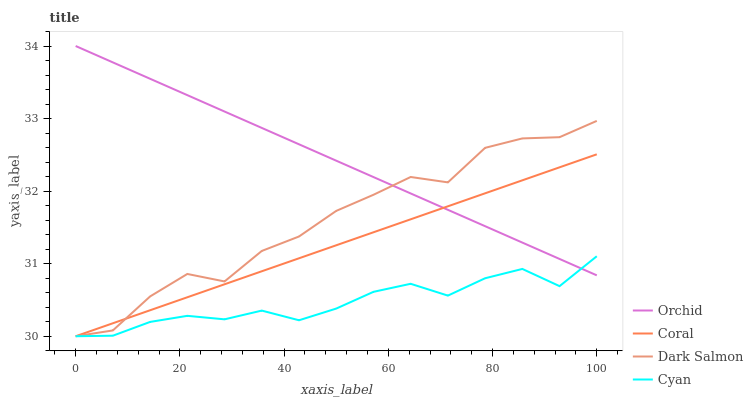Does Cyan have the minimum area under the curve?
Answer yes or no. Yes. Does Orchid have the maximum area under the curve?
Answer yes or no. Yes. Does Coral have the minimum area under the curve?
Answer yes or no. No. Does Coral have the maximum area under the curve?
Answer yes or no. No. Is Orchid the smoothest?
Answer yes or no. Yes. Is Dark Salmon the roughest?
Answer yes or no. Yes. Is Coral the smoothest?
Answer yes or no. No. Is Coral the roughest?
Answer yes or no. No. Does Orchid have the lowest value?
Answer yes or no. No. Does Orchid have the highest value?
Answer yes or no. Yes. Does Coral have the highest value?
Answer yes or no. No. 